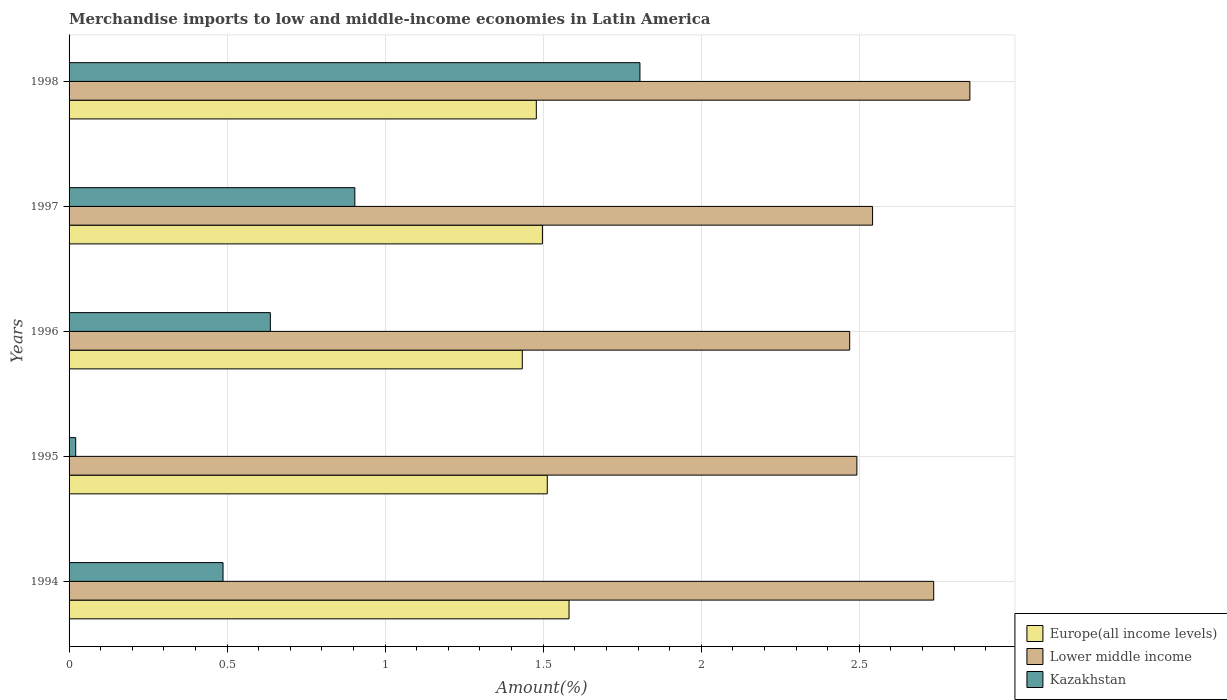What is the label of the 1st group of bars from the top?
Provide a succinct answer. 1998. What is the percentage of amount earned from merchandise imports in Lower middle income in 1997?
Your answer should be very brief. 2.54. Across all years, what is the maximum percentage of amount earned from merchandise imports in Kazakhstan?
Provide a succinct answer. 1.81. Across all years, what is the minimum percentage of amount earned from merchandise imports in Kazakhstan?
Your answer should be compact. 0.02. What is the total percentage of amount earned from merchandise imports in Europe(all income levels) in the graph?
Give a very brief answer. 7.5. What is the difference between the percentage of amount earned from merchandise imports in Europe(all income levels) in 1994 and that in 1997?
Provide a succinct answer. 0.08. What is the difference between the percentage of amount earned from merchandise imports in Europe(all income levels) in 1994 and the percentage of amount earned from merchandise imports in Lower middle income in 1997?
Keep it short and to the point. -0.96. What is the average percentage of amount earned from merchandise imports in Kazakhstan per year?
Your response must be concise. 0.77. In the year 1995, what is the difference between the percentage of amount earned from merchandise imports in Lower middle income and percentage of amount earned from merchandise imports in Kazakhstan?
Give a very brief answer. 2.47. In how many years, is the percentage of amount earned from merchandise imports in Lower middle income greater than 1.2 %?
Offer a terse response. 5. What is the ratio of the percentage of amount earned from merchandise imports in Kazakhstan in 1994 to that in 1998?
Make the answer very short. 0.27. What is the difference between the highest and the second highest percentage of amount earned from merchandise imports in Europe(all income levels)?
Offer a terse response. 0.07. What is the difference between the highest and the lowest percentage of amount earned from merchandise imports in Kazakhstan?
Make the answer very short. 1.79. In how many years, is the percentage of amount earned from merchandise imports in Lower middle income greater than the average percentage of amount earned from merchandise imports in Lower middle income taken over all years?
Your answer should be compact. 2. Is the sum of the percentage of amount earned from merchandise imports in Europe(all income levels) in 1996 and 1997 greater than the maximum percentage of amount earned from merchandise imports in Kazakhstan across all years?
Provide a short and direct response. Yes. What does the 3rd bar from the top in 1994 represents?
Give a very brief answer. Europe(all income levels). What does the 1st bar from the bottom in 1997 represents?
Keep it short and to the point. Europe(all income levels). Is it the case that in every year, the sum of the percentage of amount earned from merchandise imports in Lower middle income and percentage of amount earned from merchandise imports in Kazakhstan is greater than the percentage of amount earned from merchandise imports in Europe(all income levels)?
Your answer should be very brief. Yes. How many bars are there?
Your answer should be very brief. 15. Are all the bars in the graph horizontal?
Offer a terse response. Yes. What is the difference between two consecutive major ticks on the X-axis?
Your answer should be compact. 0.5. Are the values on the major ticks of X-axis written in scientific E-notation?
Make the answer very short. No. Does the graph contain any zero values?
Provide a short and direct response. No. Where does the legend appear in the graph?
Keep it short and to the point. Bottom right. How many legend labels are there?
Provide a short and direct response. 3. How are the legend labels stacked?
Your answer should be very brief. Vertical. What is the title of the graph?
Your response must be concise. Merchandise imports to low and middle-income economies in Latin America. What is the label or title of the X-axis?
Offer a very short reply. Amount(%). What is the label or title of the Y-axis?
Offer a very short reply. Years. What is the Amount(%) in Europe(all income levels) in 1994?
Keep it short and to the point. 1.58. What is the Amount(%) in Lower middle income in 1994?
Offer a terse response. 2.74. What is the Amount(%) in Kazakhstan in 1994?
Ensure brevity in your answer.  0.49. What is the Amount(%) in Europe(all income levels) in 1995?
Provide a short and direct response. 1.51. What is the Amount(%) in Lower middle income in 1995?
Provide a succinct answer. 2.49. What is the Amount(%) in Kazakhstan in 1995?
Offer a terse response. 0.02. What is the Amount(%) of Europe(all income levels) in 1996?
Your answer should be very brief. 1.43. What is the Amount(%) in Lower middle income in 1996?
Offer a terse response. 2.47. What is the Amount(%) of Kazakhstan in 1996?
Give a very brief answer. 0.64. What is the Amount(%) of Europe(all income levels) in 1997?
Keep it short and to the point. 1.5. What is the Amount(%) in Lower middle income in 1997?
Keep it short and to the point. 2.54. What is the Amount(%) in Kazakhstan in 1997?
Your response must be concise. 0.9. What is the Amount(%) in Europe(all income levels) in 1998?
Provide a succinct answer. 1.48. What is the Amount(%) in Lower middle income in 1998?
Give a very brief answer. 2.85. What is the Amount(%) of Kazakhstan in 1998?
Provide a succinct answer. 1.81. Across all years, what is the maximum Amount(%) in Europe(all income levels)?
Your response must be concise. 1.58. Across all years, what is the maximum Amount(%) in Lower middle income?
Your answer should be compact. 2.85. Across all years, what is the maximum Amount(%) in Kazakhstan?
Give a very brief answer. 1.81. Across all years, what is the minimum Amount(%) in Europe(all income levels)?
Offer a very short reply. 1.43. Across all years, what is the minimum Amount(%) in Lower middle income?
Offer a very short reply. 2.47. Across all years, what is the minimum Amount(%) of Kazakhstan?
Your response must be concise. 0.02. What is the total Amount(%) in Europe(all income levels) in the graph?
Your response must be concise. 7.5. What is the total Amount(%) of Lower middle income in the graph?
Your answer should be compact. 13.09. What is the total Amount(%) of Kazakhstan in the graph?
Make the answer very short. 3.86. What is the difference between the Amount(%) of Europe(all income levels) in 1994 and that in 1995?
Your response must be concise. 0.07. What is the difference between the Amount(%) of Lower middle income in 1994 and that in 1995?
Make the answer very short. 0.24. What is the difference between the Amount(%) of Kazakhstan in 1994 and that in 1995?
Offer a very short reply. 0.47. What is the difference between the Amount(%) in Europe(all income levels) in 1994 and that in 1996?
Ensure brevity in your answer.  0.15. What is the difference between the Amount(%) of Lower middle income in 1994 and that in 1996?
Your answer should be compact. 0.27. What is the difference between the Amount(%) of Kazakhstan in 1994 and that in 1996?
Provide a succinct answer. -0.15. What is the difference between the Amount(%) of Europe(all income levels) in 1994 and that in 1997?
Provide a short and direct response. 0.08. What is the difference between the Amount(%) of Lower middle income in 1994 and that in 1997?
Offer a terse response. 0.19. What is the difference between the Amount(%) of Kazakhstan in 1994 and that in 1997?
Provide a short and direct response. -0.42. What is the difference between the Amount(%) of Europe(all income levels) in 1994 and that in 1998?
Make the answer very short. 0.1. What is the difference between the Amount(%) of Lower middle income in 1994 and that in 1998?
Make the answer very short. -0.11. What is the difference between the Amount(%) of Kazakhstan in 1994 and that in 1998?
Your answer should be very brief. -1.32. What is the difference between the Amount(%) of Europe(all income levels) in 1995 and that in 1996?
Provide a short and direct response. 0.08. What is the difference between the Amount(%) in Lower middle income in 1995 and that in 1996?
Provide a succinct answer. 0.02. What is the difference between the Amount(%) in Kazakhstan in 1995 and that in 1996?
Provide a short and direct response. -0.62. What is the difference between the Amount(%) of Europe(all income levels) in 1995 and that in 1997?
Provide a succinct answer. 0.02. What is the difference between the Amount(%) of Lower middle income in 1995 and that in 1997?
Provide a short and direct response. -0.05. What is the difference between the Amount(%) in Kazakhstan in 1995 and that in 1997?
Offer a very short reply. -0.88. What is the difference between the Amount(%) in Europe(all income levels) in 1995 and that in 1998?
Keep it short and to the point. 0.03. What is the difference between the Amount(%) of Lower middle income in 1995 and that in 1998?
Offer a terse response. -0.36. What is the difference between the Amount(%) in Kazakhstan in 1995 and that in 1998?
Offer a terse response. -1.79. What is the difference between the Amount(%) in Europe(all income levels) in 1996 and that in 1997?
Keep it short and to the point. -0.06. What is the difference between the Amount(%) of Lower middle income in 1996 and that in 1997?
Give a very brief answer. -0.07. What is the difference between the Amount(%) in Kazakhstan in 1996 and that in 1997?
Your response must be concise. -0.27. What is the difference between the Amount(%) of Europe(all income levels) in 1996 and that in 1998?
Give a very brief answer. -0.04. What is the difference between the Amount(%) in Lower middle income in 1996 and that in 1998?
Keep it short and to the point. -0.38. What is the difference between the Amount(%) in Kazakhstan in 1996 and that in 1998?
Make the answer very short. -1.17. What is the difference between the Amount(%) of Europe(all income levels) in 1997 and that in 1998?
Make the answer very short. 0.02. What is the difference between the Amount(%) in Lower middle income in 1997 and that in 1998?
Your response must be concise. -0.31. What is the difference between the Amount(%) of Kazakhstan in 1997 and that in 1998?
Keep it short and to the point. -0.9. What is the difference between the Amount(%) of Europe(all income levels) in 1994 and the Amount(%) of Lower middle income in 1995?
Offer a very short reply. -0.91. What is the difference between the Amount(%) in Europe(all income levels) in 1994 and the Amount(%) in Kazakhstan in 1995?
Provide a short and direct response. 1.56. What is the difference between the Amount(%) of Lower middle income in 1994 and the Amount(%) of Kazakhstan in 1995?
Offer a terse response. 2.71. What is the difference between the Amount(%) in Europe(all income levels) in 1994 and the Amount(%) in Lower middle income in 1996?
Your answer should be compact. -0.89. What is the difference between the Amount(%) of Europe(all income levels) in 1994 and the Amount(%) of Kazakhstan in 1996?
Make the answer very short. 0.94. What is the difference between the Amount(%) in Lower middle income in 1994 and the Amount(%) in Kazakhstan in 1996?
Your answer should be compact. 2.1. What is the difference between the Amount(%) of Europe(all income levels) in 1994 and the Amount(%) of Lower middle income in 1997?
Make the answer very short. -0.96. What is the difference between the Amount(%) of Europe(all income levels) in 1994 and the Amount(%) of Kazakhstan in 1997?
Your response must be concise. 0.68. What is the difference between the Amount(%) of Lower middle income in 1994 and the Amount(%) of Kazakhstan in 1997?
Keep it short and to the point. 1.83. What is the difference between the Amount(%) in Europe(all income levels) in 1994 and the Amount(%) in Lower middle income in 1998?
Your answer should be compact. -1.27. What is the difference between the Amount(%) in Europe(all income levels) in 1994 and the Amount(%) in Kazakhstan in 1998?
Keep it short and to the point. -0.22. What is the difference between the Amount(%) in Lower middle income in 1994 and the Amount(%) in Kazakhstan in 1998?
Provide a succinct answer. 0.93. What is the difference between the Amount(%) in Europe(all income levels) in 1995 and the Amount(%) in Lower middle income in 1996?
Provide a short and direct response. -0.96. What is the difference between the Amount(%) in Europe(all income levels) in 1995 and the Amount(%) in Kazakhstan in 1996?
Offer a very short reply. 0.88. What is the difference between the Amount(%) of Lower middle income in 1995 and the Amount(%) of Kazakhstan in 1996?
Provide a succinct answer. 1.86. What is the difference between the Amount(%) of Europe(all income levels) in 1995 and the Amount(%) of Lower middle income in 1997?
Your answer should be compact. -1.03. What is the difference between the Amount(%) in Europe(all income levels) in 1995 and the Amount(%) in Kazakhstan in 1997?
Offer a terse response. 0.61. What is the difference between the Amount(%) of Lower middle income in 1995 and the Amount(%) of Kazakhstan in 1997?
Provide a succinct answer. 1.59. What is the difference between the Amount(%) in Europe(all income levels) in 1995 and the Amount(%) in Lower middle income in 1998?
Ensure brevity in your answer.  -1.34. What is the difference between the Amount(%) in Europe(all income levels) in 1995 and the Amount(%) in Kazakhstan in 1998?
Keep it short and to the point. -0.29. What is the difference between the Amount(%) of Lower middle income in 1995 and the Amount(%) of Kazakhstan in 1998?
Make the answer very short. 0.69. What is the difference between the Amount(%) in Europe(all income levels) in 1996 and the Amount(%) in Lower middle income in 1997?
Offer a terse response. -1.11. What is the difference between the Amount(%) of Europe(all income levels) in 1996 and the Amount(%) of Kazakhstan in 1997?
Offer a terse response. 0.53. What is the difference between the Amount(%) of Lower middle income in 1996 and the Amount(%) of Kazakhstan in 1997?
Provide a succinct answer. 1.57. What is the difference between the Amount(%) of Europe(all income levels) in 1996 and the Amount(%) of Lower middle income in 1998?
Your response must be concise. -1.42. What is the difference between the Amount(%) of Europe(all income levels) in 1996 and the Amount(%) of Kazakhstan in 1998?
Your answer should be very brief. -0.37. What is the difference between the Amount(%) in Lower middle income in 1996 and the Amount(%) in Kazakhstan in 1998?
Keep it short and to the point. 0.66. What is the difference between the Amount(%) of Europe(all income levels) in 1997 and the Amount(%) of Lower middle income in 1998?
Offer a terse response. -1.35. What is the difference between the Amount(%) of Europe(all income levels) in 1997 and the Amount(%) of Kazakhstan in 1998?
Provide a succinct answer. -0.31. What is the difference between the Amount(%) of Lower middle income in 1997 and the Amount(%) of Kazakhstan in 1998?
Your response must be concise. 0.74. What is the average Amount(%) of Europe(all income levels) per year?
Provide a succinct answer. 1.5. What is the average Amount(%) of Lower middle income per year?
Your answer should be compact. 2.62. What is the average Amount(%) of Kazakhstan per year?
Your answer should be very brief. 0.77. In the year 1994, what is the difference between the Amount(%) of Europe(all income levels) and Amount(%) of Lower middle income?
Make the answer very short. -1.15. In the year 1994, what is the difference between the Amount(%) in Europe(all income levels) and Amount(%) in Kazakhstan?
Ensure brevity in your answer.  1.09. In the year 1994, what is the difference between the Amount(%) of Lower middle income and Amount(%) of Kazakhstan?
Provide a short and direct response. 2.25. In the year 1995, what is the difference between the Amount(%) in Europe(all income levels) and Amount(%) in Lower middle income?
Offer a terse response. -0.98. In the year 1995, what is the difference between the Amount(%) of Europe(all income levels) and Amount(%) of Kazakhstan?
Make the answer very short. 1.49. In the year 1995, what is the difference between the Amount(%) of Lower middle income and Amount(%) of Kazakhstan?
Ensure brevity in your answer.  2.47. In the year 1996, what is the difference between the Amount(%) of Europe(all income levels) and Amount(%) of Lower middle income?
Offer a very short reply. -1.04. In the year 1996, what is the difference between the Amount(%) in Europe(all income levels) and Amount(%) in Kazakhstan?
Your answer should be compact. 0.8. In the year 1996, what is the difference between the Amount(%) of Lower middle income and Amount(%) of Kazakhstan?
Your answer should be very brief. 1.83. In the year 1997, what is the difference between the Amount(%) of Europe(all income levels) and Amount(%) of Lower middle income?
Your response must be concise. -1.04. In the year 1997, what is the difference between the Amount(%) in Europe(all income levels) and Amount(%) in Kazakhstan?
Keep it short and to the point. 0.59. In the year 1997, what is the difference between the Amount(%) of Lower middle income and Amount(%) of Kazakhstan?
Keep it short and to the point. 1.64. In the year 1998, what is the difference between the Amount(%) in Europe(all income levels) and Amount(%) in Lower middle income?
Offer a terse response. -1.37. In the year 1998, what is the difference between the Amount(%) of Europe(all income levels) and Amount(%) of Kazakhstan?
Ensure brevity in your answer.  -0.33. In the year 1998, what is the difference between the Amount(%) in Lower middle income and Amount(%) in Kazakhstan?
Your answer should be compact. 1.04. What is the ratio of the Amount(%) in Europe(all income levels) in 1994 to that in 1995?
Keep it short and to the point. 1.05. What is the ratio of the Amount(%) in Lower middle income in 1994 to that in 1995?
Offer a terse response. 1.1. What is the ratio of the Amount(%) in Kazakhstan in 1994 to that in 1995?
Give a very brief answer. 23.18. What is the ratio of the Amount(%) of Europe(all income levels) in 1994 to that in 1996?
Ensure brevity in your answer.  1.1. What is the ratio of the Amount(%) of Lower middle income in 1994 to that in 1996?
Offer a terse response. 1.11. What is the ratio of the Amount(%) of Kazakhstan in 1994 to that in 1996?
Your answer should be compact. 0.77. What is the ratio of the Amount(%) in Europe(all income levels) in 1994 to that in 1997?
Ensure brevity in your answer.  1.06. What is the ratio of the Amount(%) of Lower middle income in 1994 to that in 1997?
Your response must be concise. 1.08. What is the ratio of the Amount(%) in Kazakhstan in 1994 to that in 1997?
Keep it short and to the point. 0.54. What is the ratio of the Amount(%) of Europe(all income levels) in 1994 to that in 1998?
Make the answer very short. 1.07. What is the ratio of the Amount(%) in Lower middle income in 1994 to that in 1998?
Provide a succinct answer. 0.96. What is the ratio of the Amount(%) in Kazakhstan in 1994 to that in 1998?
Your answer should be compact. 0.27. What is the ratio of the Amount(%) in Europe(all income levels) in 1995 to that in 1996?
Your answer should be very brief. 1.06. What is the ratio of the Amount(%) of Lower middle income in 1995 to that in 1996?
Ensure brevity in your answer.  1.01. What is the ratio of the Amount(%) of Kazakhstan in 1995 to that in 1996?
Your response must be concise. 0.03. What is the ratio of the Amount(%) of Europe(all income levels) in 1995 to that in 1997?
Make the answer very short. 1.01. What is the ratio of the Amount(%) in Lower middle income in 1995 to that in 1997?
Your answer should be very brief. 0.98. What is the ratio of the Amount(%) in Kazakhstan in 1995 to that in 1997?
Your response must be concise. 0.02. What is the ratio of the Amount(%) of Europe(all income levels) in 1995 to that in 1998?
Provide a short and direct response. 1.02. What is the ratio of the Amount(%) of Lower middle income in 1995 to that in 1998?
Offer a very short reply. 0.87. What is the ratio of the Amount(%) in Kazakhstan in 1995 to that in 1998?
Keep it short and to the point. 0.01. What is the ratio of the Amount(%) of Europe(all income levels) in 1996 to that in 1997?
Keep it short and to the point. 0.96. What is the ratio of the Amount(%) in Lower middle income in 1996 to that in 1997?
Your answer should be very brief. 0.97. What is the ratio of the Amount(%) in Kazakhstan in 1996 to that in 1997?
Ensure brevity in your answer.  0.7. What is the ratio of the Amount(%) of Europe(all income levels) in 1996 to that in 1998?
Provide a short and direct response. 0.97. What is the ratio of the Amount(%) in Lower middle income in 1996 to that in 1998?
Make the answer very short. 0.87. What is the ratio of the Amount(%) of Kazakhstan in 1996 to that in 1998?
Keep it short and to the point. 0.35. What is the ratio of the Amount(%) in Europe(all income levels) in 1997 to that in 1998?
Offer a very short reply. 1.01. What is the ratio of the Amount(%) of Lower middle income in 1997 to that in 1998?
Keep it short and to the point. 0.89. What is the ratio of the Amount(%) of Kazakhstan in 1997 to that in 1998?
Offer a very short reply. 0.5. What is the difference between the highest and the second highest Amount(%) in Europe(all income levels)?
Give a very brief answer. 0.07. What is the difference between the highest and the second highest Amount(%) in Lower middle income?
Make the answer very short. 0.11. What is the difference between the highest and the second highest Amount(%) in Kazakhstan?
Your answer should be very brief. 0.9. What is the difference between the highest and the lowest Amount(%) of Europe(all income levels)?
Provide a succinct answer. 0.15. What is the difference between the highest and the lowest Amount(%) in Lower middle income?
Make the answer very short. 0.38. What is the difference between the highest and the lowest Amount(%) in Kazakhstan?
Give a very brief answer. 1.79. 